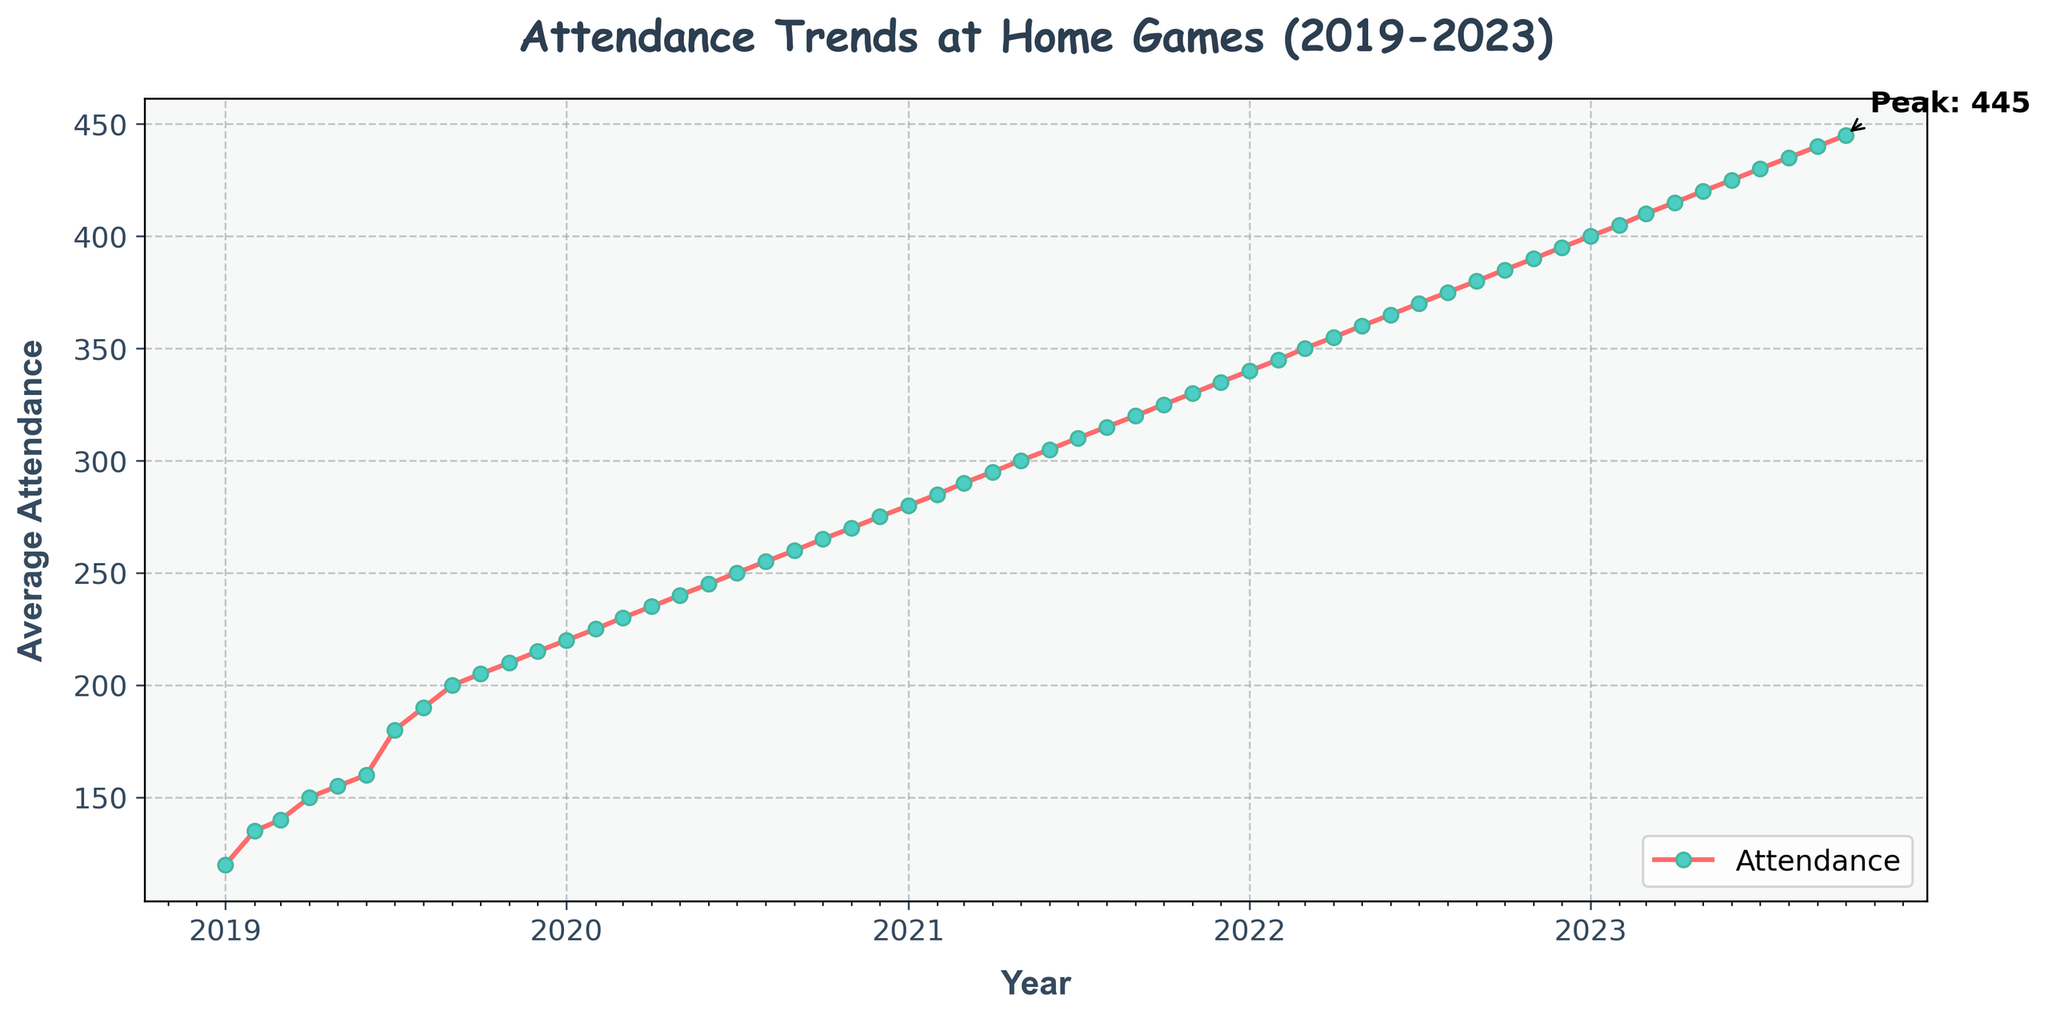What is the title of the figure? The title of the figure is displayed at the top and summarizes the main insight or content of the graph. In this case, it is prominently displayed and reads "Attendance Trends at Home Games (2019-2023)."
Answer: Attendance Trends at Home Games (2019-2023) What is the average attendance at home games in January 2019? To answer this, locate January 2019 on the x-axis and then look at the corresponding value on the y-axis. The figure shows that the average attendance for January 2019 is 120.
Answer: 120 In which year did the average attendance first reach 300? Look for the point where the y-axis value reaches 300 and then follow down to the x-axis to see the corresponding year. The line reaches 300 during the year 2021.
Answer: 2021 Which month has the highest average attendance? The peak attendance value can be identified at the highest point on the y-axis, which is 445. Trace down to the x-axis to find the corresponding month and year. The highest attendance is in October 2023.
Answer: October 2023 How has average attendance trended over the 4 years shown in the graph? Observe the general direction of the line from the start in January 2019 to the end in October 2023. The figure shows a consistent upward trend, indicating that the average attendance has increased over the 4 years.
Answer: Increased What is the difference in average attendance between January 2019 and January 2023? Locate the average attendance for both months on the y-axis: January 2019 is 120 and January 2023 is 400. Subtract the former from the latter: 400 - 120 = 280.
Answer: 280 Which year saw the most significant increase in average attendance from the previous year? Compare the differences between December of each year and the following January. The largest increase happens between December 2022 (395) and January 2023 (400), which is an increase of 5.
Answer: 2023 Can you identify a month where the attendance growth slowed down or plateaued? Look at the slope of the line for each month. If the line appears flatter compared to surrounding months, the growth has slowed. Between December 2022 and January 2023, the growth is relatively flat.
Answer: December 2022 - January 2023 